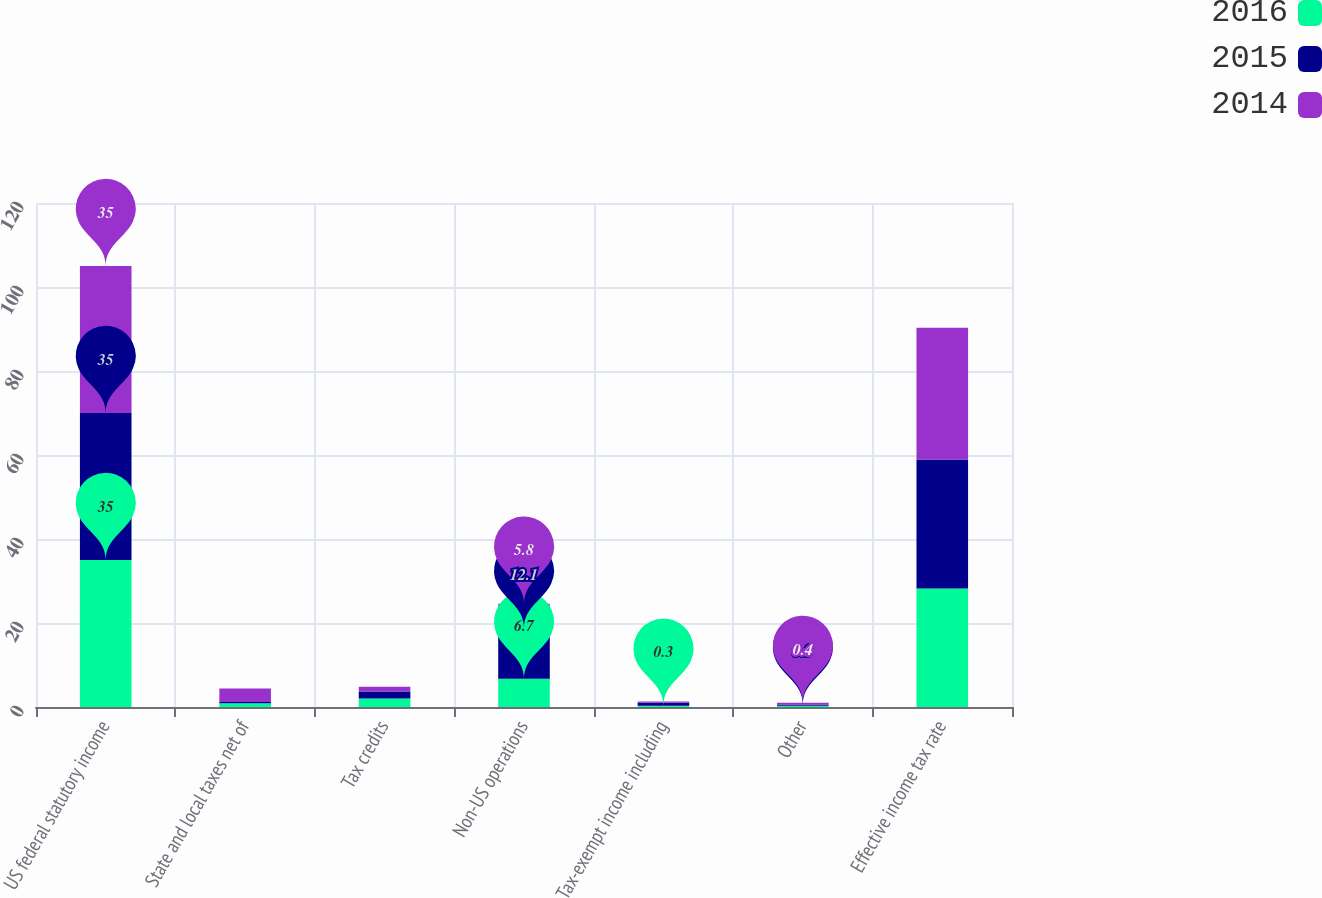Convert chart. <chart><loc_0><loc_0><loc_500><loc_500><stacked_bar_chart><ecel><fcel>US federal statutory income<fcel>State and local taxes net of<fcel>Tax credits<fcel>Non-US operations<fcel>Tax-exempt income including<fcel>Other<fcel>Effective income tax rate<nl><fcel>2016<fcel>35<fcel>0.9<fcel>2<fcel>6.7<fcel>0.3<fcel>0.3<fcel>28.2<nl><fcel>2015<fcel>35<fcel>0.3<fcel>1.7<fcel>12.1<fcel>0.7<fcel>0.3<fcel>30.7<nl><fcel>2014<fcel>35<fcel>3.2<fcel>1.1<fcel>5.8<fcel>0.3<fcel>0.4<fcel>31.4<nl></chart> 